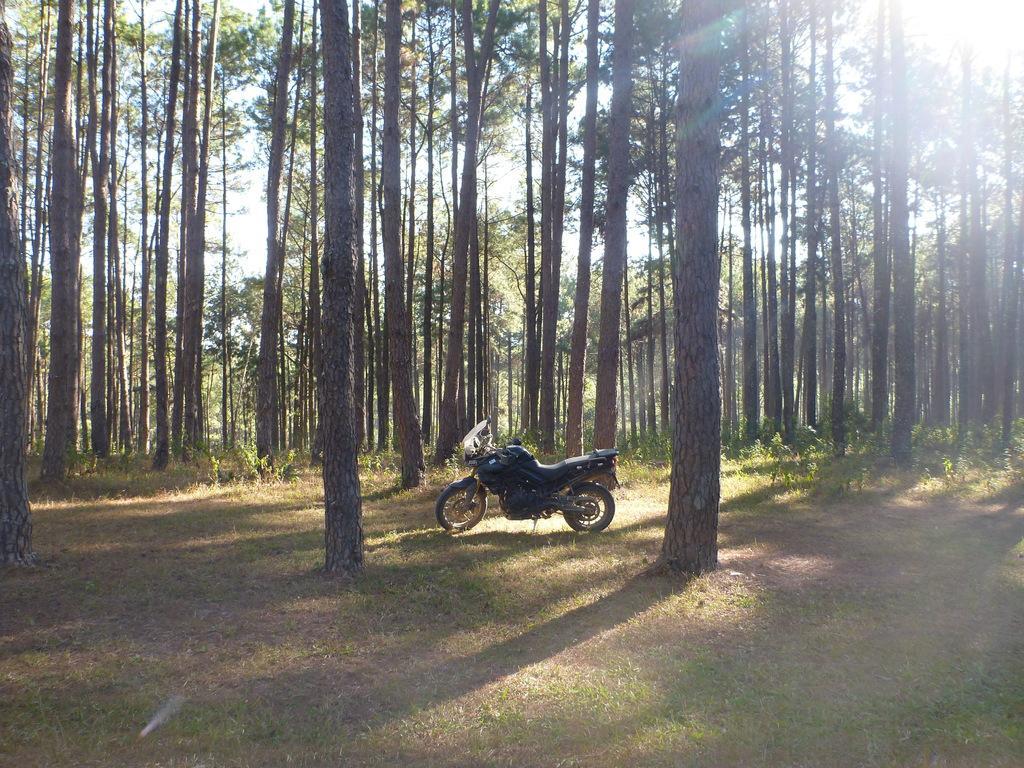Please provide a concise description of this image. Here we can see a bike parked on a side stand on the ground. In the background there are trees,grass,plants and sky. 